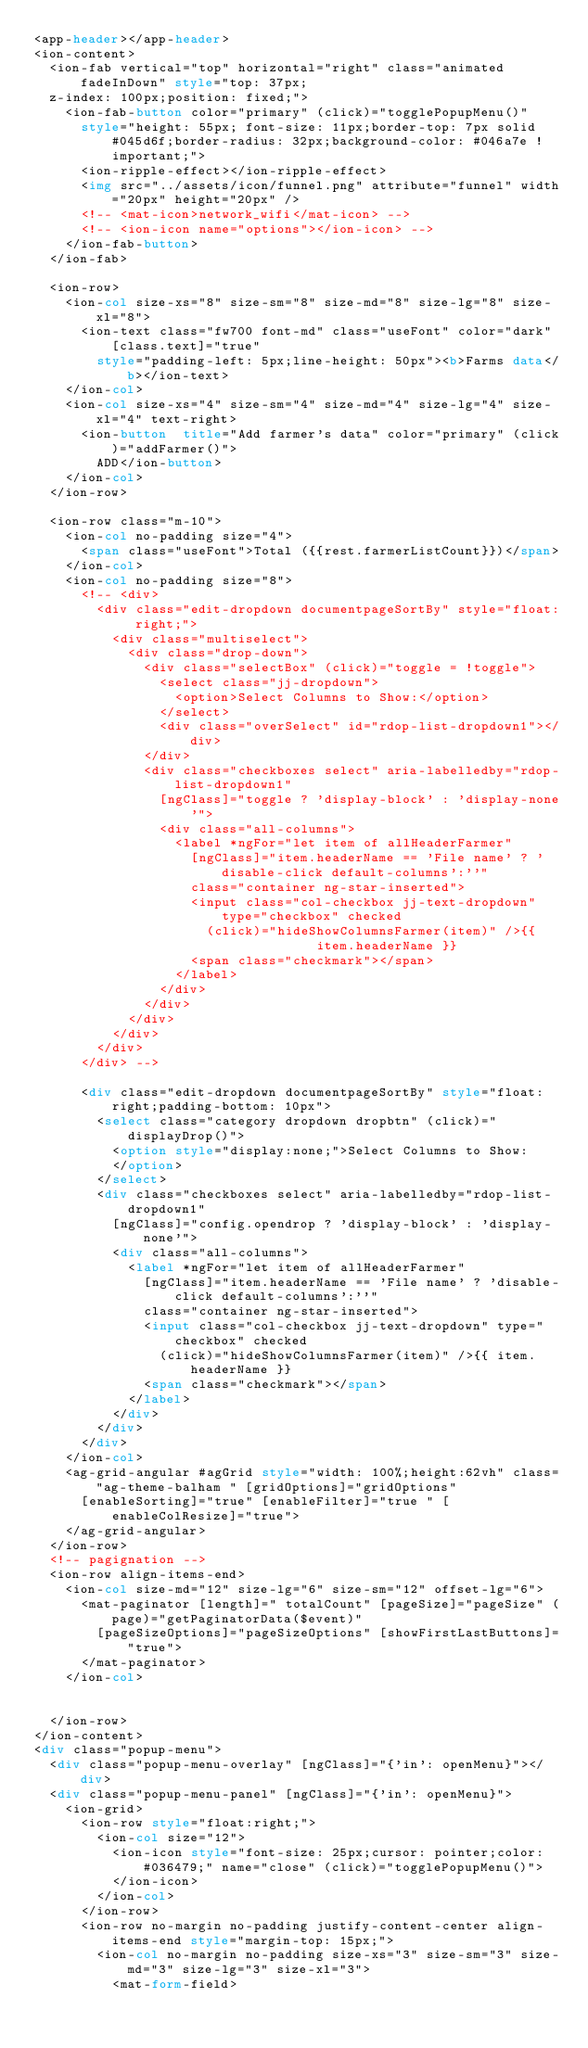<code> <loc_0><loc_0><loc_500><loc_500><_HTML_><app-header></app-header>
<ion-content>
  <ion-fab vertical="top" horizontal="right" class="animated fadeInDown" style="top: 37px;
  z-index: 100px;position: fixed;">
    <ion-fab-button color="primary" (click)="togglePopupMenu()"
      style="height: 55px; font-size: 11px;border-top: 7px solid #045d6f;border-radius: 32px;background-color: #046a7e !important;">
      <ion-ripple-effect></ion-ripple-effect>
      <img src="../assets/icon/funnel.png" attribute="funnel" width="20px" height="20px" />
      <!-- <mat-icon>network_wifi</mat-icon> -->
      <!-- <ion-icon name="options"></ion-icon> -->
    </ion-fab-button>
  </ion-fab>

  <ion-row>
    <ion-col size-xs="8" size-sm="8" size-md="8" size-lg="8" size-xl="8">
      <ion-text class="fw700 font-md" class="useFont" color="dark" [class.text]="true"
        style="padding-left: 5px;line-height: 50px"><b>Farms data</b></ion-text>
    </ion-col>
    <ion-col size-xs="4" size-sm="4" size-md="4" size-lg="4" size-xl="4" text-right>
      <ion-button  title="Add farmer's data" color="primary" (click)="addFarmer()">
        ADD</ion-button>
    </ion-col>
  </ion-row>

  <ion-row class="m-10">
    <ion-col no-padding size="4">
      <span class="useFont">Total ({{rest.farmerListCount}})</span>
    </ion-col>
    <ion-col no-padding size="8">
      <!-- <div>
        <div class="edit-dropdown documentpageSortBy" style="float: right;">
          <div class="multiselect">
            <div class="drop-down">
              <div class="selectBox" (click)="toggle = !toggle">
                <select class="jj-dropdown">
                  <option>Select Columns to Show:</option>
                </select>
                <div class="overSelect" id="rdop-list-dropdown1"></div>
              </div>
              <div class="checkboxes select" aria-labelledby="rdop-list-dropdown1"
                [ngClass]="toggle ? 'display-block' : 'display-none'">
                <div class="all-columns">
                  <label *ngFor="let item of allHeaderFarmer"
                    [ngClass]="item.headerName == 'File name' ? 'disable-click default-columns':''"
                    class="container ng-star-inserted">
                    <input class="col-checkbox jj-text-dropdown" type="checkbox" checked
                      (click)="hideShowColumnsFarmer(item)" />{{
                                    item.headerName }}
                    <span class="checkmark"></span>
                  </label>
                </div>
              </div>
            </div>
          </div>
        </div>
      </div> -->

      <div class="edit-dropdown documentpageSortBy" style="float: right;padding-bottom: 10px">
        <select class="category dropdown dropbtn" (click)="displayDrop()">
          <option style="display:none;">Select Columns to Show:
          </option>
        </select>
        <div class="checkboxes select" aria-labelledby="rdop-list-dropdown1"
          [ngClass]="config.opendrop ? 'display-block' : 'display-none'">
          <div class="all-columns">
            <label *ngFor="let item of allHeaderFarmer"
              [ngClass]="item.headerName == 'File name' ? 'disable-click default-columns':''"
              class="container ng-star-inserted">
              <input class="col-checkbox jj-text-dropdown" type="checkbox" checked
                (click)="hideShowColumnsFarmer(item)" />{{ item.headerName }}
              <span class="checkmark"></span>
            </label>
          </div>
        </div>
      </div>
    </ion-col>
    <ag-grid-angular #agGrid style="width: 100%;height:62vh" class="ag-theme-balham " [gridOptions]="gridOptions"
      [enableSorting]="true" [enableFilter]="true " [enableColResize]="true">
    </ag-grid-angular>
  </ion-row>
  <!-- pagignation -->
  <ion-row align-items-end>
    <ion-col size-md="12" size-lg="6" size-sm="12" offset-lg="6">
      <mat-paginator [length]=" totalCount" [pageSize]="pageSize" (page)="getPaginatorData($event)"
        [pageSizeOptions]="pageSizeOptions" [showFirstLastButtons]="true">
      </mat-paginator>
    </ion-col>


  </ion-row>
</ion-content>
<div class="popup-menu">
  <div class="popup-menu-overlay" [ngClass]="{'in': openMenu}"></div>
  <div class="popup-menu-panel" [ngClass]="{'in': openMenu}">
    <ion-grid>
      <ion-row style="float:right;">
        <ion-col size="12">
          <ion-icon style="font-size: 25px;cursor: pointer;color: #036479;" name="close" (click)="togglePopupMenu()">
          </ion-icon>
        </ion-col>
      </ion-row>
      <ion-row no-margin no-padding justify-content-center align-items-end style="margin-top: 15px;">
        <ion-col no-margin no-padding size-xs="3" size-sm="3" size-md="3" size-lg="3" size-xl="3">
          <mat-form-field></code> 